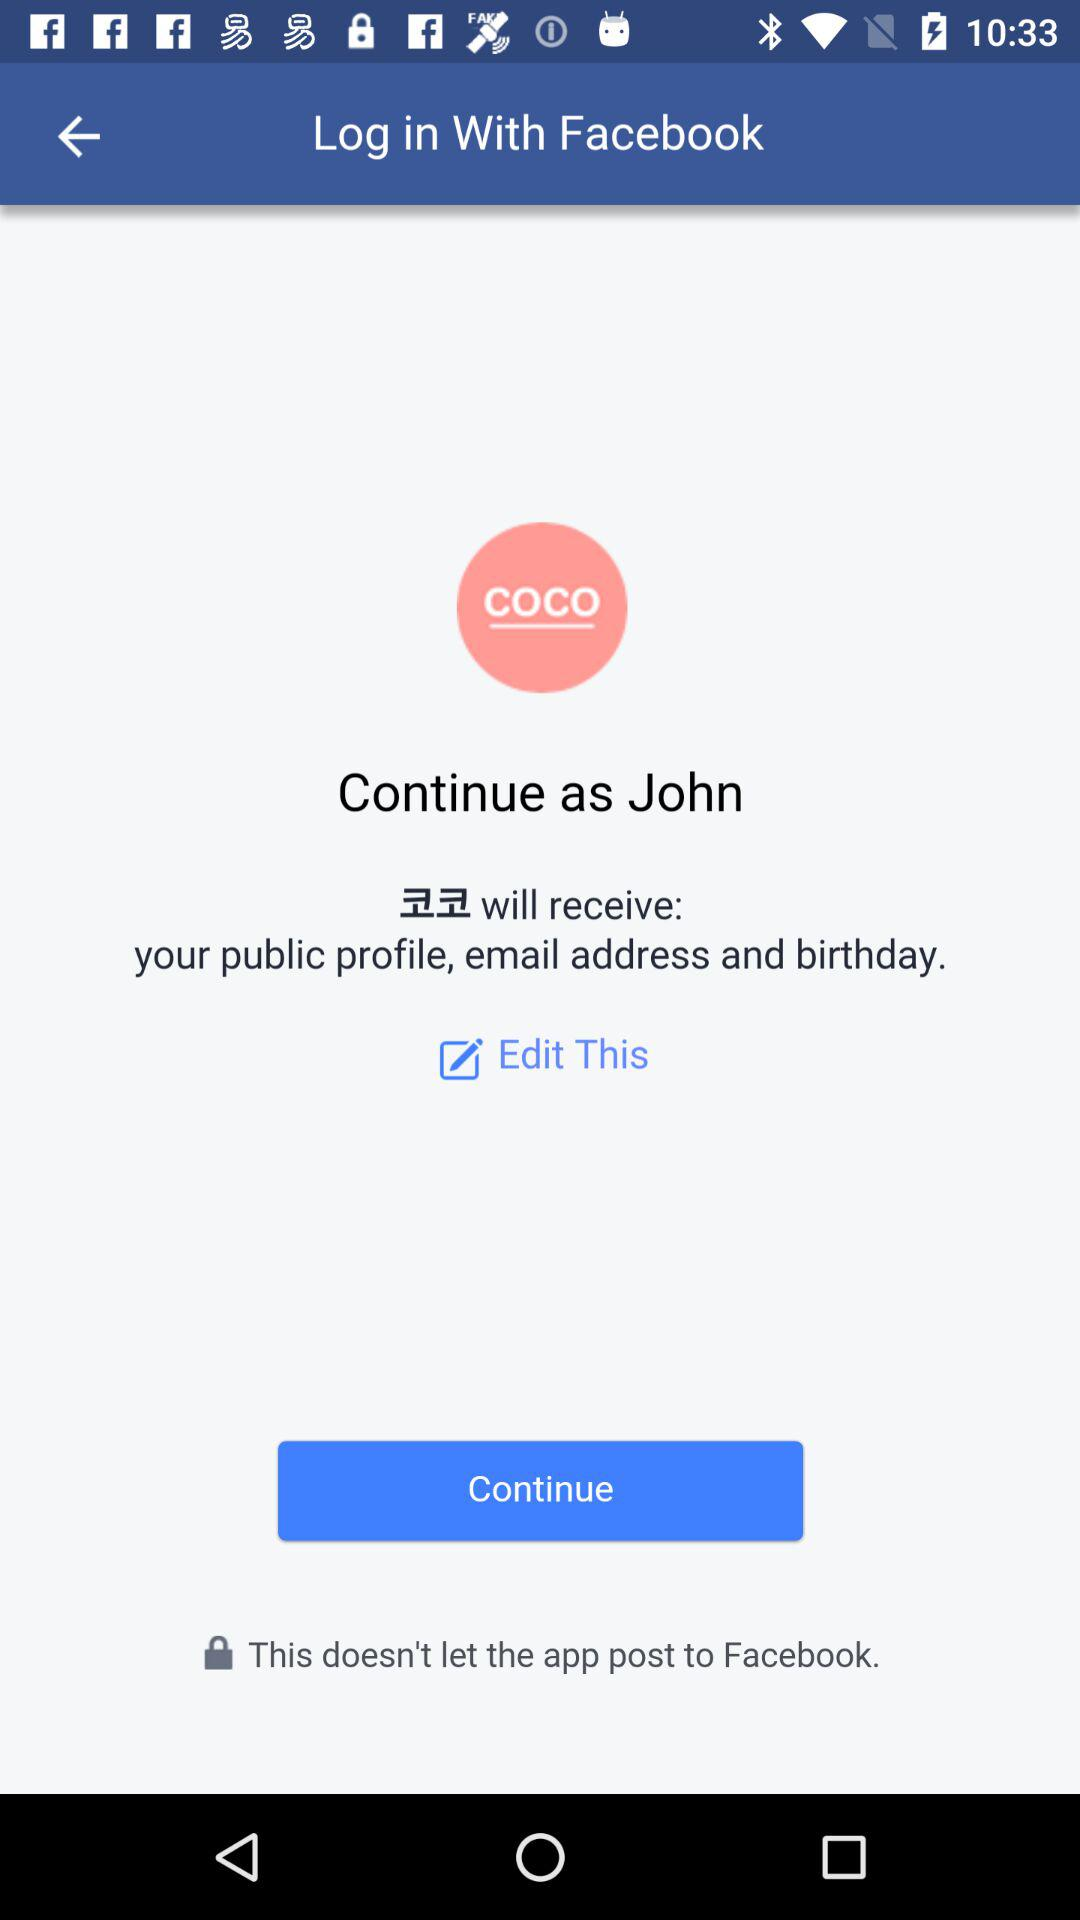What is the website to access?
When the provided information is insufficient, respond with <no answer>. <no answer> 